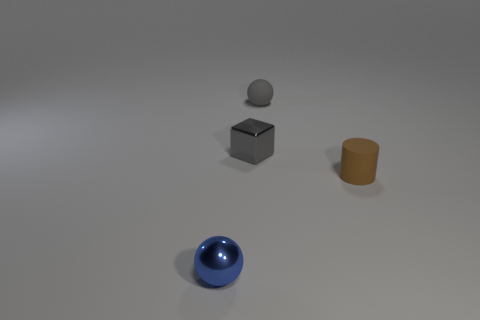Can you describe the positioning of the objects relative to each other? Certainly! The objects are placed in a roughly triangular formation. A blue spherical object is in the foreground, a grey metallic cube is centered, and a brown cylindrical object is off to the right side. Above the metallic cube hovers a small grey sphere, directly aligned vertically with the cube. 